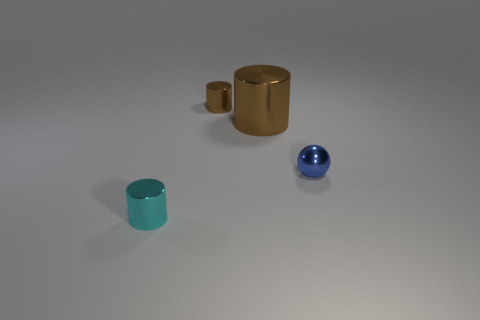Add 4 big matte cylinders. How many objects exist? 8 Subtract all cylinders. How many objects are left? 1 Add 4 big metal cylinders. How many big metal cylinders are left? 5 Add 4 tiny blue metallic objects. How many tiny blue metallic objects exist? 5 Subtract 0 yellow cubes. How many objects are left? 4 Subtract all small metal balls. Subtract all brown shiny objects. How many objects are left? 1 